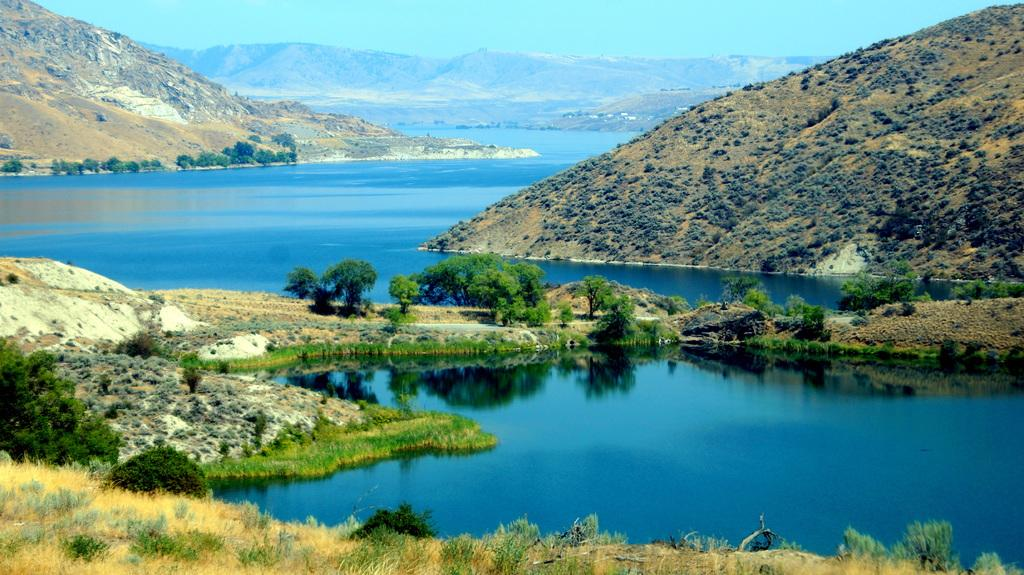What is one of the natural elements visible in the image? Water is visible in the image. What type of vegetation can be seen in the image? There are trees and plants in the image. What geographical feature is present in the image? There are hills in the image. What part of the natural environment is visible in the image? The sky is visible in the image. What type of copper berry can be seen growing on the trees in the image? There is no copper berry present in the image, as the trees are not described as having any specific type of fruit or berry. 